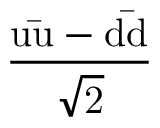<formula> <loc_0><loc_0><loc_500><loc_500>\frac { u { \bar { u } } - d { \bar { d } } } { \sqrt { 2 } }</formula> 